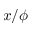Convert formula to latex. <formula><loc_0><loc_0><loc_500><loc_500>x / \phi</formula> 